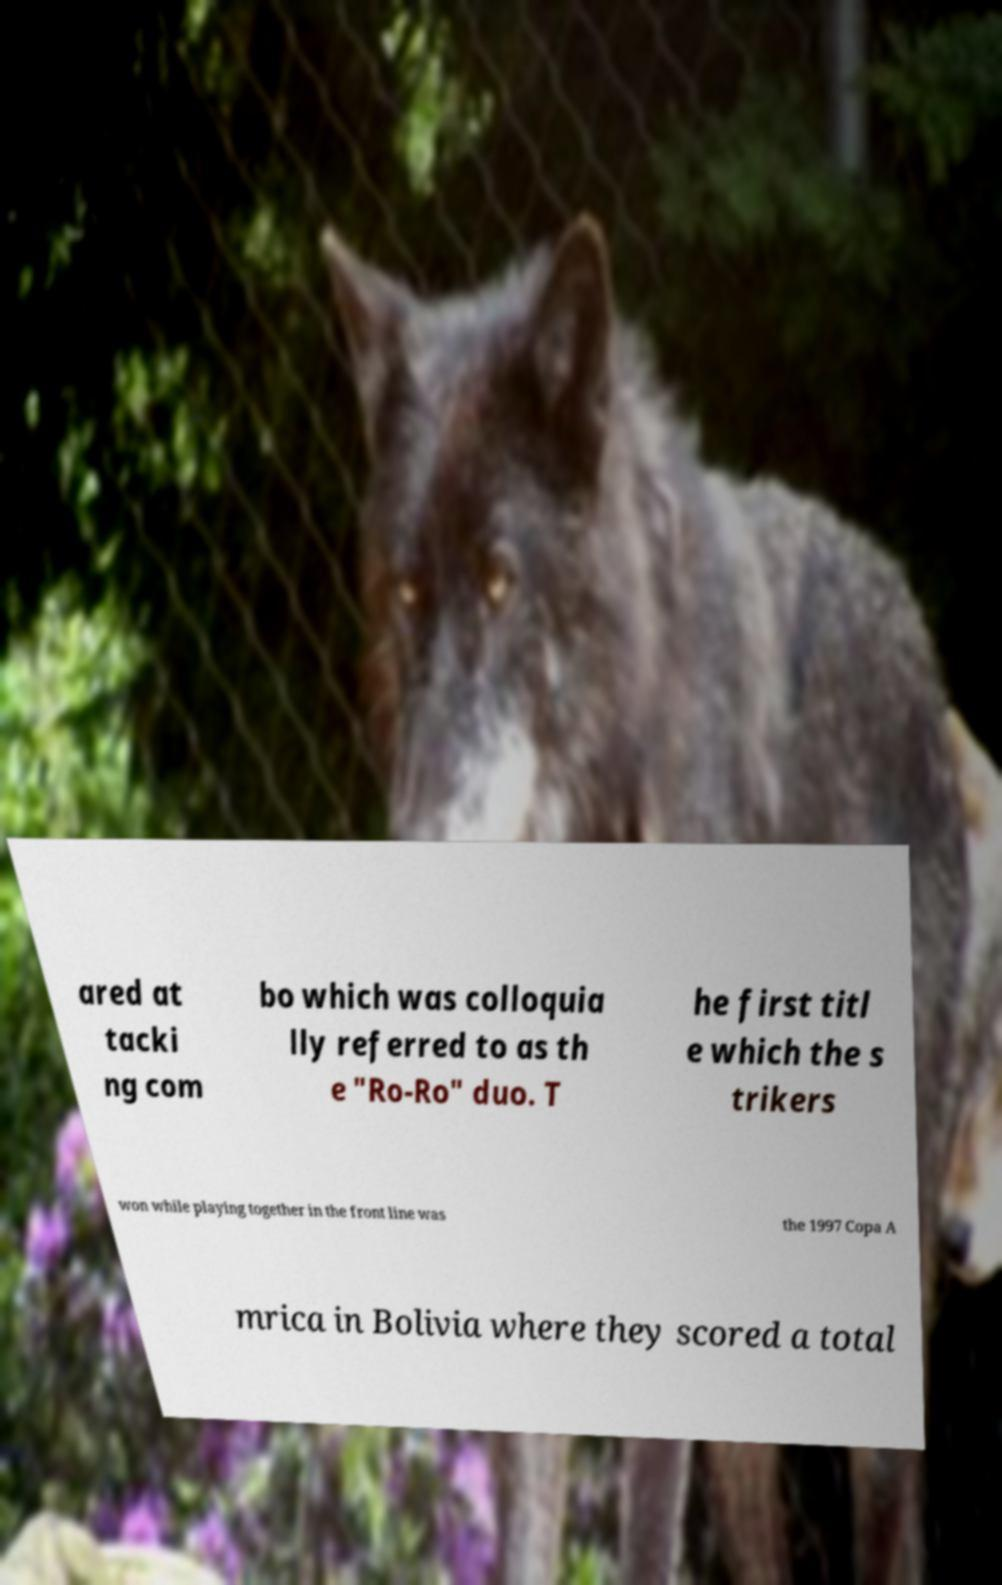Please read and relay the text visible in this image. What does it say? ared at tacki ng com bo which was colloquia lly referred to as th e "Ro-Ro" duo. T he first titl e which the s trikers won while playing together in the front line was the 1997 Copa A mrica in Bolivia where they scored a total 